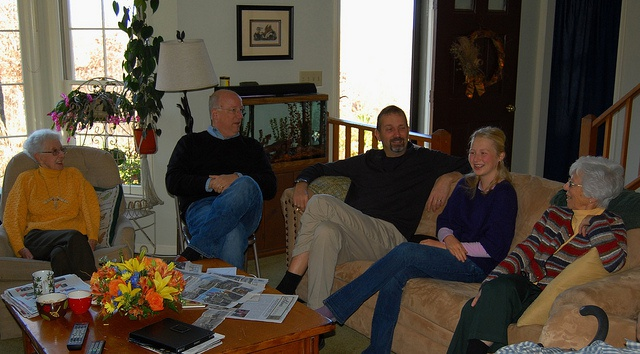Describe the objects in this image and their specific colors. I can see people in ivory, black, gray, and maroon tones, people in white, black, brown, maroon, and gray tones, people in white, black, gray, and maroon tones, people in white, black, navy, and maroon tones, and couch in white, maroon, and olive tones in this image. 